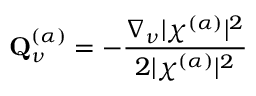<formula> <loc_0><loc_0><loc_500><loc_500>Q _ { \nu } ^ { ( \alpha ) } = - \frac { \nabla _ { \nu } | \chi ^ { ( \alpha ) } | ^ { 2 } } { 2 | \chi ^ { ( \alpha ) } | ^ { 2 } }</formula> 